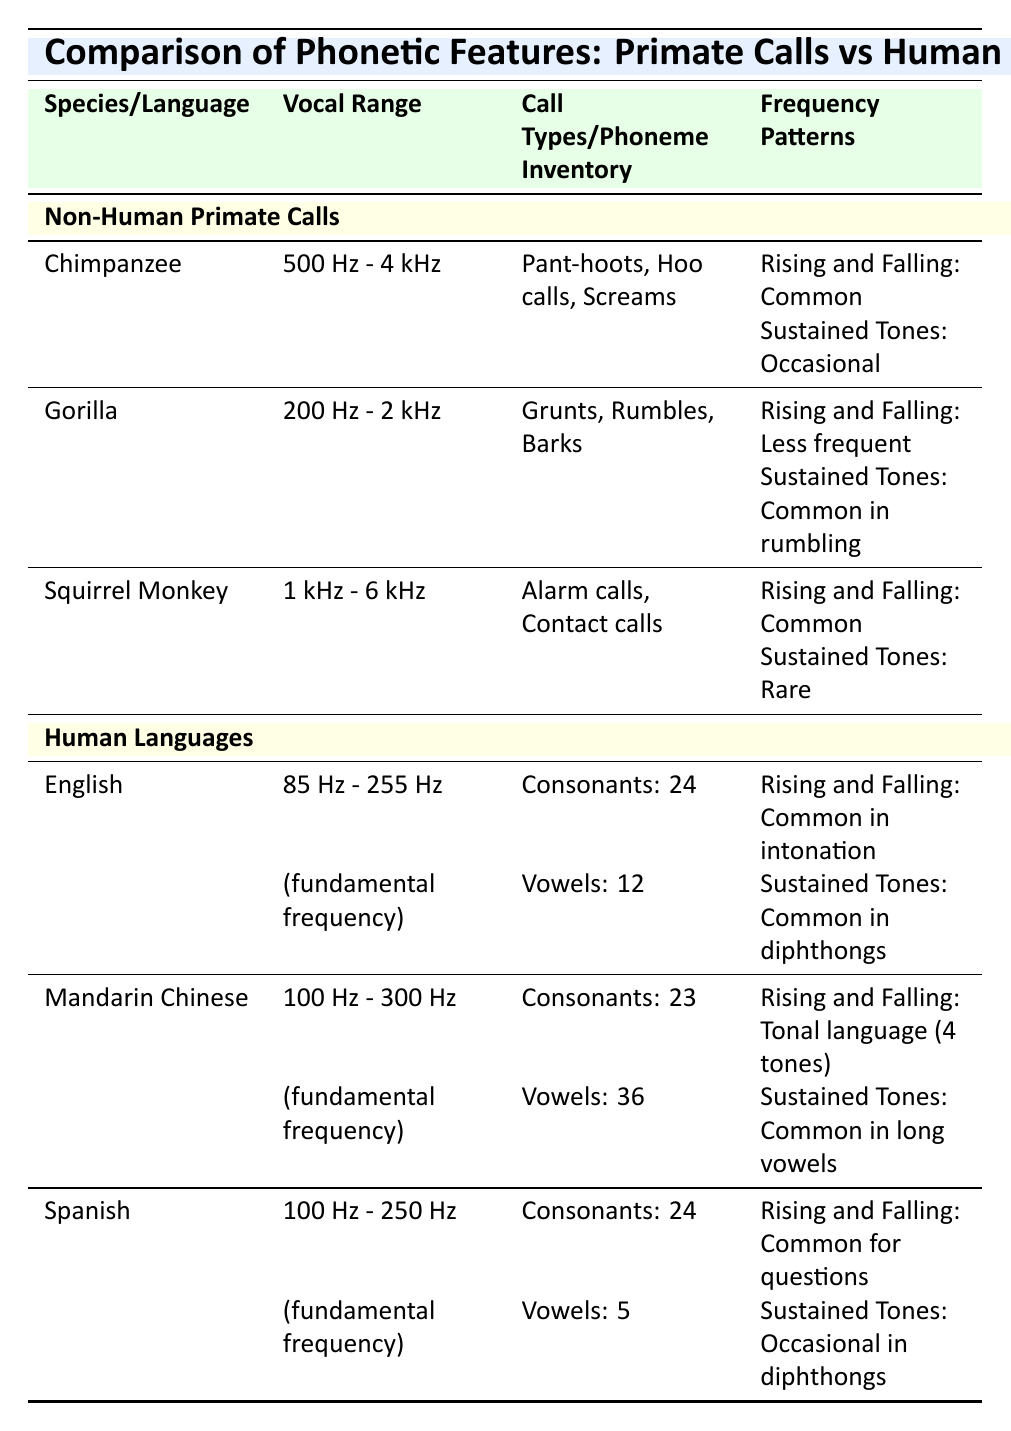What is the vocal range of chimpanzees? The table indicates that the vocal range of chimpanzees is 500 Hz - 4 kHz because this specific information is provided in the row under "Chimpanzee."
Answer: 500 Hz - 4 kHz Which non-human primate has sustained tones common in their vocalizations? From the table, we can see that gorillas have sustained tones that are common in their rumbling calls. This is explicitly mentioned in the "Frequency Patterns" section for gorillas.
Answer: Gorilla Does Spanish have more phonemes than Mandarin Chinese? By checking the "Phoneme Inventory" rows for both languages, Spanish has 24 consonants and 5 vowels (total 29), versus Mandarin Chinese which has 23 consonants and 36 vowels (total 59), thus the statement is false.
Answer: No What is the difference in vocal range between the Squirrel Monkey and the Gorilla? The vocal range for the Squirrel Monkey is 1 kHz - 6 kHz and for the Gorilla is 200 Hz - 2 kHz. To find the difference: Squirrel Monkey's upper limit (6 kHz) minus Gorilla's upper limit (2 kHz) gives 6 kHz - 2 kHz = 4 kHz. So the difference in the upper limits is 4 kHz.
Answer: 4 kHz How many total vowel sounds are represented in English and Spanish combined? From the table, English has 12 vowels and Spanish has 5 vowels. Adding these figures together gives: 12 + 5 = 17. Thus, the total number of vowel sounds in both languages combined is 17.
Answer: 17 Are the frequency patterns of non-human primate calls and human languages entirely different? The table details that both categories have "Rising and Falling" patterns, found in both non-human primate calls (mostly common) and human languages (common in various contexts), indicating that there is a similarity. Thus, the statement is false.
Answer: No Identify a common call type for Squirrel Monkeys. The table indicates that Squirrel Monkeys make Alarm calls and Contact calls. This information can be found in the "Call Types" section for Squirrel Monkeys.
Answer: Alarm calls, Contact calls Which language has the highest number of vowels? The table shows that Mandarin Chinese has 36 vowels, while English has 12 vowels and Spanish has 5 vowels. Thus, Mandarin Chinese has the highest number of vowels.
Answer: Mandarin Chinese 